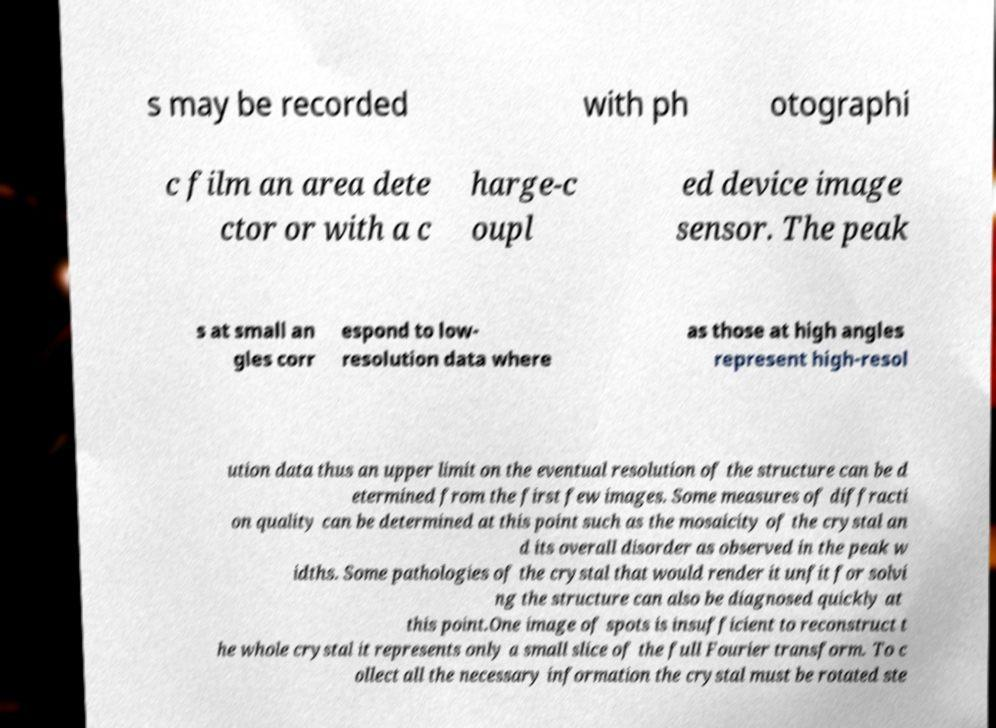Please identify and transcribe the text found in this image. s may be recorded with ph otographi c film an area dete ctor or with a c harge-c oupl ed device image sensor. The peak s at small an gles corr espond to low- resolution data where as those at high angles represent high-resol ution data thus an upper limit on the eventual resolution of the structure can be d etermined from the first few images. Some measures of diffracti on quality can be determined at this point such as the mosaicity of the crystal an d its overall disorder as observed in the peak w idths. Some pathologies of the crystal that would render it unfit for solvi ng the structure can also be diagnosed quickly at this point.One image of spots is insufficient to reconstruct t he whole crystal it represents only a small slice of the full Fourier transform. To c ollect all the necessary information the crystal must be rotated ste 